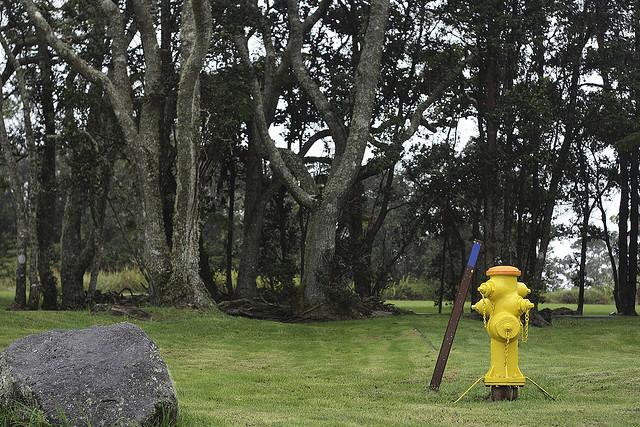Where is the fire hydrant?
Answer briefly. Grass. What color is the hydrant?
Answer briefly. Yellow. Is a shadow cast?
Keep it brief. No. Is the rock in the trees?
Be succinct. No. 